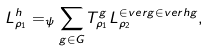Convert formula to latex. <formula><loc_0><loc_0><loc_500><loc_500>L _ { \rho _ { 1 } } ^ { h } = _ { \psi } \sum _ { g \in G } T _ { \rho _ { 1 } } ^ { g } L _ { \rho _ { 2 } } ^ { \in v e r g \in v e r h g } ,</formula> 